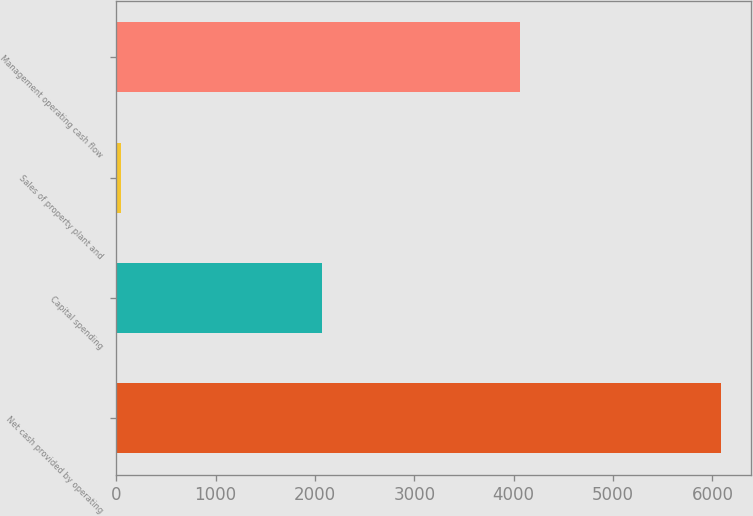Convert chart to OTSL. <chart><loc_0><loc_0><loc_500><loc_500><bar_chart><fcel>Net cash provided by operating<fcel>Capital spending<fcel>Sales of property plant and<fcel>Management operating cash flow<nl><fcel>6084<fcel>2068<fcel>49<fcel>4065<nl></chart> 